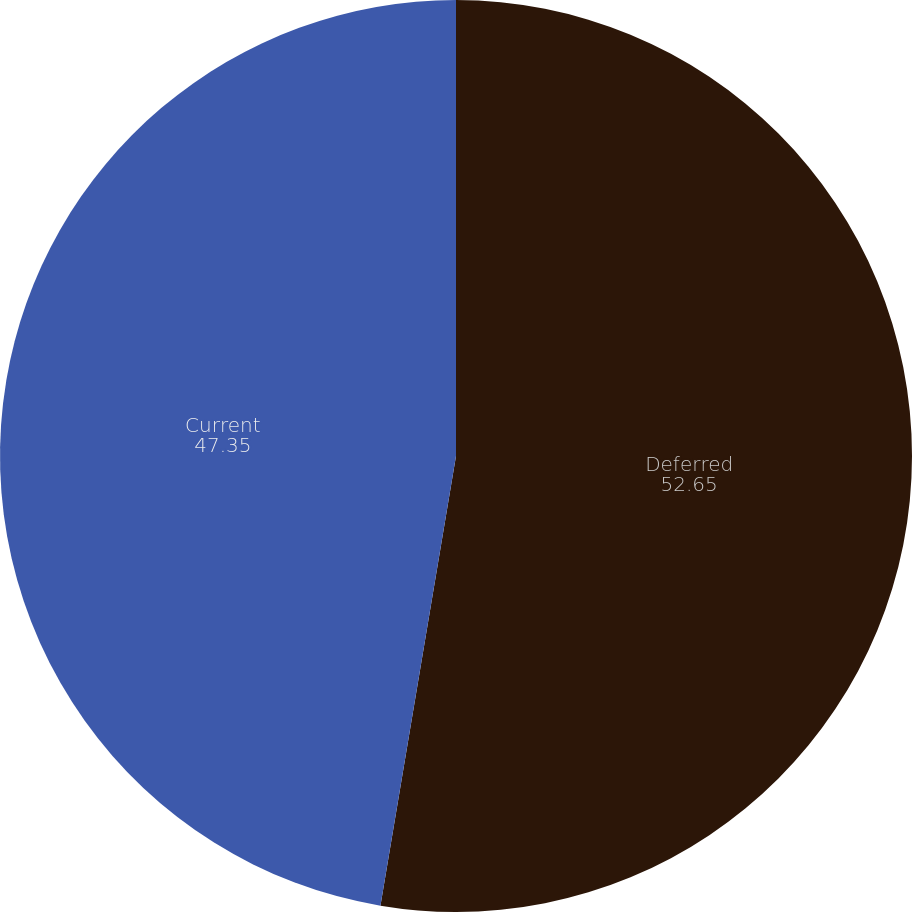Convert chart to OTSL. <chart><loc_0><loc_0><loc_500><loc_500><pie_chart><fcel>Deferred<fcel>Current<nl><fcel>52.65%<fcel>47.35%<nl></chart> 